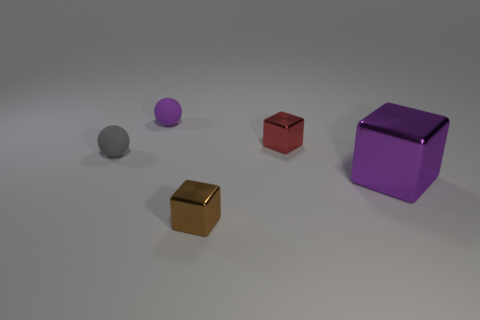What number of objects are either tiny gray spheres or purple balls?
Give a very brief answer. 2. Is the purple object that is behind the big block made of the same material as the large thing?
Provide a short and direct response. No. How many things are either tiny objects that are in front of the purple ball or purple spheres?
Your answer should be compact. 4. There is a thing that is made of the same material as the small gray ball; what is its color?
Offer a very short reply. Purple. Are there any brown things that have the same size as the gray rubber sphere?
Offer a very short reply. Yes. Do the small ball behind the red block and the large thing have the same color?
Give a very brief answer. Yes. There is a object that is both in front of the small red thing and behind the large purple thing; what is its color?
Give a very brief answer. Gray. There is a purple object that is the same size as the brown block; what shape is it?
Ensure brevity in your answer.  Sphere. Is there a large metal object that has the same shape as the tiny brown object?
Your answer should be very brief. Yes. Is the size of the purple thing on the left side of the brown cube the same as the purple metallic thing?
Your response must be concise. No. 